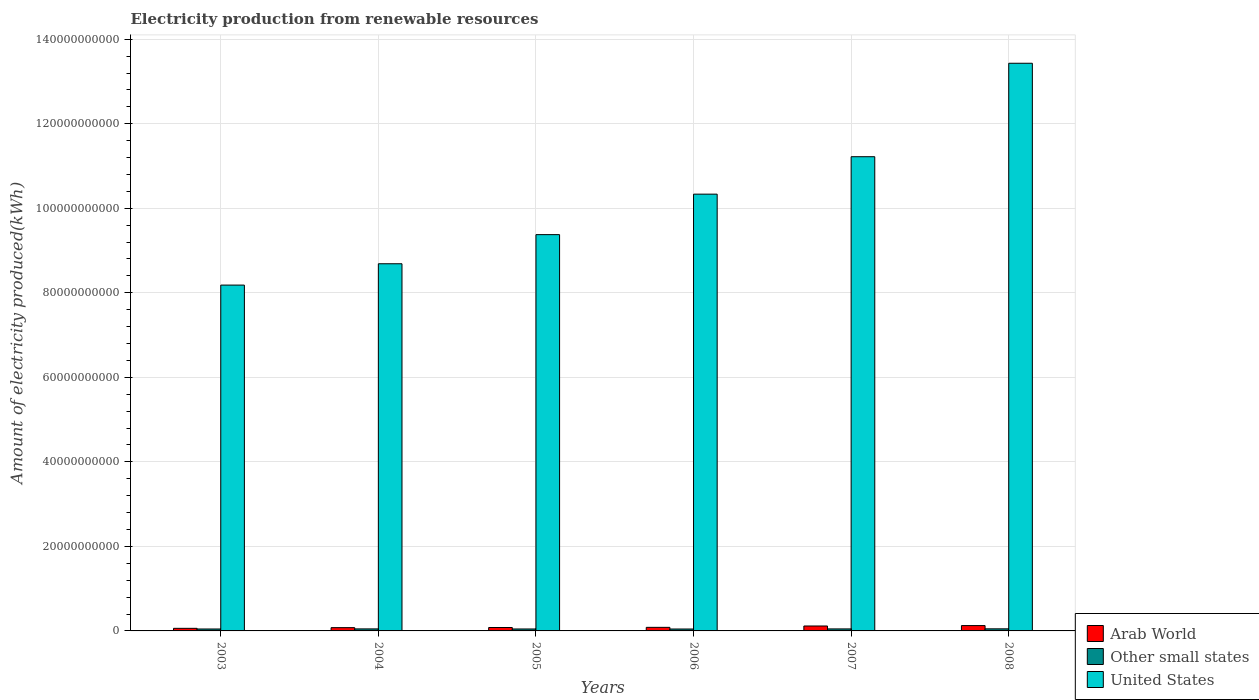How many different coloured bars are there?
Make the answer very short. 3. How many groups of bars are there?
Offer a very short reply. 6. Are the number of bars on each tick of the X-axis equal?
Give a very brief answer. Yes. In how many cases, is the number of bars for a given year not equal to the number of legend labels?
Keep it short and to the point. 0. What is the amount of electricity produced in Other small states in 2007?
Ensure brevity in your answer.  4.76e+08. Across all years, what is the maximum amount of electricity produced in Other small states?
Keep it short and to the point. 4.94e+08. Across all years, what is the minimum amount of electricity produced in Arab World?
Your response must be concise. 6.13e+08. What is the total amount of electricity produced in Arab World in the graph?
Give a very brief answer. 5.47e+09. What is the difference between the amount of electricity produced in United States in 2003 and that in 2008?
Offer a very short reply. -5.25e+1. What is the difference between the amount of electricity produced in Other small states in 2008 and the amount of electricity produced in United States in 2007?
Provide a short and direct response. -1.12e+11. What is the average amount of electricity produced in Other small states per year?
Your answer should be compact. 4.70e+08. In the year 2005, what is the difference between the amount of electricity produced in United States and amount of electricity produced in Arab World?
Give a very brief answer. 9.30e+1. What is the ratio of the amount of electricity produced in Arab World in 2006 to that in 2007?
Offer a very short reply. 0.73. Is the amount of electricity produced in Arab World in 2004 less than that in 2008?
Ensure brevity in your answer.  Yes. What is the difference between the highest and the second highest amount of electricity produced in Arab World?
Ensure brevity in your answer.  9.60e+07. What is the difference between the highest and the lowest amount of electricity produced in Other small states?
Provide a short and direct response. 4.00e+07. Is the sum of the amount of electricity produced in United States in 2004 and 2005 greater than the maximum amount of electricity produced in Other small states across all years?
Your response must be concise. Yes. What does the 2nd bar from the left in 2008 represents?
Give a very brief answer. Other small states. What does the 3rd bar from the right in 2005 represents?
Your answer should be compact. Arab World. Is it the case that in every year, the sum of the amount of electricity produced in Other small states and amount of electricity produced in United States is greater than the amount of electricity produced in Arab World?
Your response must be concise. Yes. How many bars are there?
Offer a very short reply. 18. Are all the bars in the graph horizontal?
Make the answer very short. No. How many years are there in the graph?
Your response must be concise. 6. What is the difference between two consecutive major ticks on the Y-axis?
Your response must be concise. 2.00e+1. Are the values on the major ticks of Y-axis written in scientific E-notation?
Your answer should be very brief. No. Does the graph contain any zero values?
Provide a succinct answer. No. Does the graph contain grids?
Ensure brevity in your answer.  Yes. Where does the legend appear in the graph?
Your answer should be compact. Bottom right. What is the title of the graph?
Keep it short and to the point. Electricity production from renewable resources. Does "Greece" appear as one of the legend labels in the graph?
Offer a very short reply. No. What is the label or title of the Y-axis?
Your answer should be very brief. Amount of electricity produced(kWh). What is the Amount of electricity produced(kWh) of Arab World in 2003?
Make the answer very short. 6.13e+08. What is the Amount of electricity produced(kWh) in Other small states in 2003?
Keep it short and to the point. 4.57e+08. What is the Amount of electricity produced(kWh) of United States in 2003?
Provide a succinct answer. 8.18e+1. What is the Amount of electricity produced(kWh) in Arab World in 2004?
Keep it short and to the point. 7.75e+08. What is the Amount of electricity produced(kWh) of Other small states in 2004?
Keep it short and to the point. 4.78e+08. What is the Amount of electricity produced(kWh) in United States in 2004?
Keep it short and to the point. 8.69e+1. What is the Amount of electricity produced(kWh) of Arab World in 2005?
Ensure brevity in your answer.  8.08e+08. What is the Amount of electricity produced(kWh) in Other small states in 2005?
Offer a very short reply. 4.61e+08. What is the Amount of electricity produced(kWh) in United States in 2005?
Keep it short and to the point. 9.38e+1. What is the Amount of electricity produced(kWh) in Arab World in 2006?
Give a very brief answer. 8.46e+08. What is the Amount of electricity produced(kWh) in Other small states in 2006?
Offer a very short reply. 4.54e+08. What is the Amount of electricity produced(kWh) of United States in 2006?
Keep it short and to the point. 1.03e+11. What is the Amount of electricity produced(kWh) of Arab World in 2007?
Your response must be concise. 1.17e+09. What is the Amount of electricity produced(kWh) in Other small states in 2007?
Provide a short and direct response. 4.76e+08. What is the Amount of electricity produced(kWh) in United States in 2007?
Provide a short and direct response. 1.12e+11. What is the Amount of electricity produced(kWh) of Arab World in 2008?
Provide a succinct answer. 1.26e+09. What is the Amount of electricity produced(kWh) in Other small states in 2008?
Your answer should be compact. 4.94e+08. What is the Amount of electricity produced(kWh) in United States in 2008?
Your response must be concise. 1.34e+11. Across all years, what is the maximum Amount of electricity produced(kWh) of Arab World?
Make the answer very short. 1.26e+09. Across all years, what is the maximum Amount of electricity produced(kWh) in Other small states?
Provide a succinct answer. 4.94e+08. Across all years, what is the maximum Amount of electricity produced(kWh) in United States?
Make the answer very short. 1.34e+11. Across all years, what is the minimum Amount of electricity produced(kWh) of Arab World?
Ensure brevity in your answer.  6.13e+08. Across all years, what is the minimum Amount of electricity produced(kWh) of Other small states?
Keep it short and to the point. 4.54e+08. Across all years, what is the minimum Amount of electricity produced(kWh) in United States?
Your answer should be compact. 8.18e+1. What is the total Amount of electricity produced(kWh) in Arab World in the graph?
Keep it short and to the point. 5.47e+09. What is the total Amount of electricity produced(kWh) in Other small states in the graph?
Offer a very short reply. 2.82e+09. What is the total Amount of electricity produced(kWh) of United States in the graph?
Keep it short and to the point. 6.12e+11. What is the difference between the Amount of electricity produced(kWh) in Arab World in 2003 and that in 2004?
Ensure brevity in your answer.  -1.62e+08. What is the difference between the Amount of electricity produced(kWh) in Other small states in 2003 and that in 2004?
Keep it short and to the point. -2.10e+07. What is the difference between the Amount of electricity produced(kWh) in United States in 2003 and that in 2004?
Make the answer very short. -5.04e+09. What is the difference between the Amount of electricity produced(kWh) of Arab World in 2003 and that in 2005?
Offer a very short reply. -1.95e+08. What is the difference between the Amount of electricity produced(kWh) of Other small states in 2003 and that in 2005?
Provide a succinct answer. -4.00e+06. What is the difference between the Amount of electricity produced(kWh) of United States in 2003 and that in 2005?
Provide a short and direct response. -1.19e+1. What is the difference between the Amount of electricity produced(kWh) in Arab World in 2003 and that in 2006?
Provide a short and direct response. -2.33e+08. What is the difference between the Amount of electricity produced(kWh) in United States in 2003 and that in 2006?
Ensure brevity in your answer.  -2.15e+1. What is the difference between the Amount of electricity produced(kWh) of Arab World in 2003 and that in 2007?
Keep it short and to the point. -5.53e+08. What is the difference between the Amount of electricity produced(kWh) of Other small states in 2003 and that in 2007?
Make the answer very short. -1.90e+07. What is the difference between the Amount of electricity produced(kWh) in United States in 2003 and that in 2007?
Offer a very short reply. -3.04e+1. What is the difference between the Amount of electricity produced(kWh) of Arab World in 2003 and that in 2008?
Your response must be concise. -6.49e+08. What is the difference between the Amount of electricity produced(kWh) in Other small states in 2003 and that in 2008?
Offer a terse response. -3.70e+07. What is the difference between the Amount of electricity produced(kWh) of United States in 2003 and that in 2008?
Keep it short and to the point. -5.25e+1. What is the difference between the Amount of electricity produced(kWh) of Arab World in 2004 and that in 2005?
Give a very brief answer. -3.30e+07. What is the difference between the Amount of electricity produced(kWh) of Other small states in 2004 and that in 2005?
Provide a short and direct response. 1.70e+07. What is the difference between the Amount of electricity produced(kWh) in United States in 2004 and that in 2005?
Give a very brief answer. -6.89e+09. What is the difference between the Amount of electricity produced(kWh) of Arab World in 2004 and that in 2006?
Offer a terse response. -7.10e+07. What is the difference between the Amount of electricity produced(kWh) of Other small states in 2004 and that in 2006?
Keep it short and to the point. 2.40e+07. What is the difference between the Amount of electricity produced(kWh) of United States in 2004 and that in 2006?
Ensure brevity in your answer.  -1.65e+1. What is the difference between the Amount of electricity produced(kWh) in Arab World in 2004 and that in 2007?
Offer a very short reply. -3.91e+08. What is the difference between the Amount of electricity produced(kWh) in United States in 2004 and that in 2007?
Give a very brief answer. -2.53e+1. What is the difference between the Amount of electricity produced(kWh) in Arab World in 2004 and that in 2008?
Keep it short and to the point. -4.87e+08. What is the difference between the Amount of electricity produced(kWh) in Other small states in 2004 and that in 2008?
Give a very brief answer. -1.60e+07. What is the difference between the Amount of electricity produced(kWh) of United States in 2004 and that in 2008?
Provide a succinct answer. -4.74e+1. What is the difference between the Amount of electricity produced(kWh) of Arab World in 2005 and that in 2006?
Provide a short and direct response. -3.80e+07. What is the difference between the Amount of electricity produced(kWh) of Other small states in 2005 and that in 2006?
Offer a terse response. 7.00e+06. What is the difference between the Amount of electricity produced(kWh) of United States in 2005 and that in 2006?
Your answer should be compact. -9.58e+09. What is the difference between the Amount of electricity produced(kWh) of Arab World in 2005 and that in 2007?
Your response must be concise. -3.58e+08. What is the difference between the Amount of electricity produced(kWh) of Other small states in 2005 and that in 2007?
Give a very brief answer. -1.50e+07. What is the difference between the Amount of electricity produced(kWh) in United States in 2005 and that in 2007?
Provide a succinct answer. -1.84e+1. What is the difference between the Amount of electricity produced(kWh) in Arab World in 2005 and that in 2008?
Ensure brevity in your answer.  -4.54e+08. What is the difference between the Amount of electricity produced(kWh) of Other small states in 2005 and that in 2008?
Make the answer very short. -3.30e+07. What is the difference between the Amount of electricity produced(kWh) in United States in 2005 and that in 2008?
Keep it short and to the point. -4.05e+1. What is the difference between the Amount of electricity produced(kWh) of Arab World in 2006 and that in 2007?
Offer a terse response. -3.20e+08. What is the difference between the Amount of electricity produced(kWh) of Other small states in 2006 and that in 2007?
Give a very brief answer. -2.20e+07. What is the difference between the Amount of electricity produced(kWh) of United States in 2006 and that in 2007?
Make the answer very short. -8.86e+09. What is the difference between the Amount of electricity produced(kWh) in Arab World in 2006 and that in 2008?
Give a very brief answer. -4.16e+08. What is the difference between the Amount of electricity produced(kWh) of Other small states in 2006 and that in 2008?
Provide a short and direct response. -4.00e+07. What is the difference between the Amount of electricity produced(kWh) in United States in 2006 and that in 2008?
Provide a succinct answer. -3.10e+1. What is the difference between the Amount of electricity produced(kWh) of Arab World in 2007 and that in 2008?
Your response must be concise. -9.60e+07. What is the difference between the Amount of electricity produced(kWh) in Other small states in 2007 and that in 2008?
Make the answer very short. -1.80e+07. What is the difference between the Amount of electricity produced(kWh) of United States in 2007 and that in 2008?
Provide a succinct answer. -2.21e+1. What is the difference between the Amount of electricity produced(kWh) in Arab World in 2003 and the Amount of electricity produced(kWh) in Other small states in 2004?
Make the answer very short. 1.35e+08. What is the difference between the Amount of electricity produced(kWh) of Arab World in 2003 and the Amount of electricity produced(kWh) of United States in 2004?
Provide a succinct answer. -8.63e+1. What is the difference between the Amount of electricity produced(kWh) in Other small states in 2003 and the Amount of electricity produced(kWh) in United States in 2004?
Ensure brevity in your answer.  -8.64e+1. What is the difference between the Amount of electricity produced(kWh) in Arab World in 2003 and the Amount of electricity produced(kWh) in Other small states in 2005?
Provide a short and direct response. 1.52e+08. What is the difference between the Amount of electricity produced(kWh) in Arab World in 2003 and the Amount of electricity produced(kWh) in United States in 2005?
Provide a succinct answer. -9.31e+1. What is the difference between the Amount of electricity produced(kWh) in Other small states in 2003 and the Amount of electricity produced(kWh) in United States in 2005?
Your answer should be very brief. -9.33e+1. What is the difference between the Amount of electricity produced(kWh) in Arab World in 2003 and the Amount of electricity produced(kWh) in Other small states in 2006?
Make the answer very short. 1.59e+08. What is the difference between the Amount of electricity produced(kWh) of Arab World in 2003 and the Amount of electricity produced(kWh) of United States in 2006?
Your response must be concise. -1.03e+11. What is the difference between the Amount of electricity produced(kWh) of Other small states in 2003 and the Amount of electricity produced(kWh) of United States in 2006?
Offer a terse response. -1.03e+11. What is the difference between the Amount of electricity produced(kWh) of Arab World in 2003 and the Amount of electricity produced(kWh) of Other small states in 2007?
Make the answer very short. 1.37e+08. What is the difference between the Amount of electricity produced(kWh) of Arab World in 2003 and the Amount of electricity produced(kWh) of United States in 2007?
Offer a terse response. -1.12e+11. What is the difference between the Amount of electricity produced(kWh) of Other small states in 2003 and the Amount of electricity produced(kWh) of United States in 2007?
Offer a terse response. -1.12e+11. What is the difference between the Amount of electricity produced(kWh) of Arab World in 2003 and the Amount of electricity produced(kWh) of Other small states in 2008?
Offer a terse response. 1.19e+08. What is the difference between the Amount of electricity produced(kWh) of Arab World in 2003 and the Amount of electricity produced(kWh) of United States in 2008?
Your answer should be compact. -1.34e+11. What is the difference between the Amount of electricity produced(kWh) in Other small states in 2003 and the Amount of electricity produced(kWh) in United States in 2008?
Your answer should be compact. -1.34e+11. What is the difference between the Amount of electricity produced(kWh) in Arab World in 2004 and the Amount of electricity produced(kWh) in Other small states in 2005?
Offer a terse response. 3.14e+08. What is the difference between the Amount of electricity produced(kWh) of Arab World in 2004 and the Amount of electricity produced(kWh) of United States in 2005?
Provide a short and direct response. -9.30e+1. What is the difference between the Amount of electricity produced(kWh) in Other small states in 2004 and the Amount of electricity produced(kWh) in United States in 2005?
Ensure brevity in your answer.  -9.33e+1. What is the difference between the Amount of electricity produced(kWh) of Arab World in 2004 and the Amount of electricity produced(kWh) of Other small states in 2006?
Provide a short and direct response. 3.21e+08. What is the difference between the Amount of electricity produced(kWh) of Arab World in 2004 and the Amount of electricity produced(kWh) of United States in 2006?
Offer a terse response. -1.03e+11. What is the difference between the Amount of electricity produced(kWh) of Other small states in 2004 and the Amount of electricity produced(kWh) of United States in 2006?
Your response must be concise. -1.03e+11. What is the difference between the Amount of electricity produced(kWh) of Arab World in 2004 and the Amount of electricity produced(kWh) of Other small states in 2007?
Make the answer very short. 2.99e+08. What is the difference between the Amount of electricity produced(kWh) in Arab World in 2004 and the Amount of electricity produced(kWh) in United States in 2007?
Provide a succinct answer. -1.11e+11. What is the difference between the Amount of electricity produced(kWh) in Other small states in 2004 and the Amount of electricity produced(kWh) in United States in 2007?
Provide a succinct answer. -1.12e+11. What is the difference between the Amount of electricity produced(kWh) of Arab World in 2004 and the Amount of electricity produced(kWh) of Other small states in 2008?
Your answer should be compact. 2.81e+08. What is the difference between the Amount of electricity produced(kWh) in Arab World in 2004 and the Amount of electricity produced(kWh) in United States in 2008?
Your answer should be very brief. -1.34e+11. What is the difference between the Amount of electricity produced(kWh) in Other small states in 2004 and the Amount of electricity produced(kWh) in United States in 2008?
Offer a very short reply. -1.34e+11. What is the difference between the Amount of electricity produced(kWh) in Arab World in 2005 and the Amount of electricity produced(kWh) in Other small states in 2006?
Provide a short and direct response. 3.54e+08. What is the difference between the Amount of electricity produced(kWh) in Arab World in 2005 and the Amount of electricity produced(kWh) in United States in 2006?
Ensure brevity in your answer.  -1.03e+11. What is the difference between the Amount of electricity produced(kWh) in Other small states in 2005 and the Amount of electricity produced(kWh) in United States in 2006?
Keep it short and to the point. -1.03e+11. What is the difference between the Amount of electricity produced(kWh) in Arab World in 2005 and the Amount of electricity produced(kWh) in Other small states in 2007?
Ensure brevity in your answer.  3.32e+08. What is the difference between the Amount of electricity produced(kWh) of Arab World in 2005 and the Amount of electricity produced(kWh) of United States in 2007?
Offer a terse response. -1.11e+11. What is the difference between the Amount of electricity produced(kWh) of Other small states in 2005 and the Amount of electricity produced(kWh) of United States in 2007?
Provide a succinct answer. -1.12e+11. What is the difference between the Amount of electricity produced(kWh) of Arab World in 2005 and the Amount of electricity produced(kWh) of Other small states in 2008?
Make the answer very short. 3.14e+08. What is the difference between the Amount of electricity produced(kWh) in Arab World in 2005 and the Amount of electricity produced(kWh) in United States in 2008?
Your answer should be very brief. -1.33e+11. What is the difference between the Amount of electricity produced(kWh) of Other small states in 2005 and the Amount of electricity produced(kWh) of United States in 2008?
Keep it short and to the point. -1.34e+11. What is the difference between the Amount of electricity produced(kWh) in Arab World in 2006 and the Amount of electricity produced(kWh) in Other small states in 2007?
Provide a short and direct response. 3.70e+08. What is the difference between the Amount of electricity produced(kWh) of Arab World in 2006 and the Amount of electricity produced(kWh) of United States in 2007?
Give a very brief answer. -1.11e+11. What is the difference between the Amount of electricity produced(kWh) of Other small states in 2006 and the Amount of electricity produced(kWh) of United States in 2007?
Your answer should be very brief. -1.12e+11. What is the difference between the Amount of electricity produced(kWh) in Arab World in 2006 and the Amount of electricity produced(kWh) in Other small states in 2008?
Your response must be concise. 3.52e+08. What is the difference between the Amount of electricity produced(kWh) in Arab World in 2006 and the Amount of electricity produced(kWh) in United States in 2008?
Ensure brevity in your answer.  -1.33e+11. What is the difference between the Amount of electricity produced(kWh) in Other small states in 2006 and the Amount of electricity produced(kWh) in United States in 2008?
Your answer should be very brief. -1.34e+11. What is the difference between the Amount of electricity produced(kWh) of Arab World in 2007 and the Amount of electricity produced(kWh) of Other small states in 2008?
Make the answer very short. 6.72e+08. What is the difference between the Amount of electricity produced(kWh) in Arab World in 2007 and the Amount of electricity produced(kWh) in United States in 2008?
Keep it short and to the point. -1.33e+11. What is the difference between the Amount of electricity produced(kWh) of Other small states in 2007 and the Amount of electricity produced(kWh) of United States in 2008?
Make the answer very short. -1.34e+11. What is the average Amount of electricity produced(kWh) in Arab World per year?
Give a very brief answer. 9.12e+08. What is the average Amount of electricity produced(kWh) in Other small states per year?
Provide a short and direct response. 4.70e+08. What is the average Amount of electricity produced(kWh) in United States per year?
Offer a terse response. 1.02e+11. In the year 2003, what is the difference between the Amount of electricity produced(kWh) of Arab World and Amount of electricity produced(kWh) of Other small states?
Ensure brevity in your answer.  1.56e+08. In the year 2003, what is the difference between the Amount of electricity produced(kWh) of Arab World and Amount of electricity produced(kWh) of United States?
Keep it short and to the point. -8.12e+1. In the year 2003, what is the difference between the Amount of electricity produced(kWh) of Other small states and Amount of electricity produced(kWh) of United States?
Your response must be concise. -8.14e+1. In the year 2004, what is the difference between the Amount of electricity produced(kWh) in Arab World and Amount of electricity produced(kWh) in Other small states?
Make the answer very short. 2.97e+08. In the year 2004, what is the difference between the Amount of electricity produced(kWh) of Arab World and Amount of electricity produced(kWh) of United States?
Give a very brief answer. -8.61e+1. In the year 2004, what is the difference between the Amount of electricity produced(kWh) in Other small states and Amount of electricity produced(kWh) in United States?
Make the answer very short. -8.64e+1. In the year 2005, what is the difference between the Amount of electricity produced(kWh) in Arab World and Amount of electricity produced(kWh) in Other small states?
Make the answer very short. 3.47e+08. In the year 2005, what is the difference between the Amount of electricity produced(kWh) in Arab World and Amount of electricity produced(kWh) in United States?
Your answer should be compact. -9.30e+1. In the year 2005, what is the difference between the Amount of electricity produced(kWh) of Other small states and Amount of electricity produced(kWh) of United States?
Make the answer very short. -9.33e+1. In the year 2006, what is the difference between the Amount of electricity produced(kWh) of Arab World and Amount of electricity produced(kWh) of Other small states?
Your answer should be compact. 3.92e+08. In the year 2006, what is the difference between the Amount of electricity produced(kWh) in Arab World and Amount of electricity produced(kWh) in United States?
Offer a terse response. -1.02e+11. In the year 2006, what is the difference between the Amount of electricity produced(kWh) in Other small states and Amount of electricity produced(kWh) in United States?
Offer a terse response. -1.03e+11. In the year 2007, what is the difference between the Amount of electricity produced(kWh) in Arab World and Amount of electricity produced(kWh) in Other small states?
Provide a short and direct response. 6.90e+08. In the year 2007, what is the difference between the Amount of electricity produced(kWh) in Arab World and Amount of electricity produced(kWh) in United States?
Give a very brief answer. -1.11e+11. In the year 2007, what is the difference between the Amount of electricity produced(kWh) of Other small states and Amount of electricity produced(kWh) of United States?
Ensure brevity in your answer.  -1.12e+11. In the year 2008, what is the difference between the Amount of electricity produced(kWh) in Arab World and Amount of electricity produced(kWh) in Other small states?
Ensure brevity in your answer.  7.68e+08. In the year 2008, what is the difference between the Amount of electricity produced(kWh) of Arab World and Amount of electricity produced(kWh) of United States?
Make the answer very short. -1.33e+11. In the year 2008, what is the difference between the Amount of electricity produced(kWh) of Other small states and Amount of electricity produced(kWh) of United States?
Provide a succinct answer. -1.34e+11. What is the ratio of the Amount of electricity produced(kWh) of Arab World in 2003 to that in 2004?
Offer a very short reply. 0.79. What is the ratio of the Amount of electricity produced(kWh) of Other small states in 2003 to that in 2004?
Keep it short and to the point. 0.96. What is the ratio of the Amount of electricity produced(kWh) in United States in 2003 to that in 2004?
Your answer should be compact. 0.94. What is the ratio of the Amount of electricity produced(kWh) of Arab World in 2003 to that in 2005?
Your response must be concise. 0.76. What is the ratio of the Amount of electricity produced(kWh) in United States in 2003 to that in 2005?
Your response must be concise. 0.87. What is the ratio of the Amount of electricity produced(kWh) in Arab World in 2003 to that in 2006?
Offer a very short reply. 0.72. What is the ratio of the Amount of electricity produced(kWh) in Other small states in 2003 to that in 2006?
Keep it short and to the point. 1.01. What is the ratio of the Amount of electricity produced(kWh) in United States in 2003 to that in 2006?
Your answer should be compact. 0.79. What is the ratio of the Amount of electricity produced(kWh) in Arab World in 2003 to that in 2007?
Your answer should be compact. 0.53. What is the ratio of the Amount of electricity produced(kWh) of Other small states in 2003 to that in 2007?
Provide a succinct answer. 0.96. What is the ratio of the Amount of electricity produced(kWh) in United States in 2003 to that in 2007?
Your answer should be compact. 0.73. What is the ratio of the Amount of electricity produced(kWh) of Arab World in 2003 to that in 2008?
Your answer should be very brief. 0.49. What is the ratio of the Amount of electricity produced(kWh) in Other small states in 2003 to that in 2008?
Your answer should be compact. 0.93. What is the ratio of the Amount of electricity produced(kWh) in United States in 2003 to that in 2008?
Make the answer very short. 0.61. What is the ratio of the Amount of electricity produced(kWh) in Arab World in 2004 to that in 2005?
Make the answer very short. 0.96. What is the ratio of the Amount of electricity produced(kWh) of Other small states in 2004 to that in 2005?
Your response must be concise. 1.04. What is the ratio of the Amount of electricity produced(kWh) in United States in 2004 to that in 2005?
Ensure brevity in your answer.  0.93. What is the ratio of the Amount of electricity produced(kWh) in Arab World in 2004 to that in 2006?
Your answer should be compact. 0.92. What is the ratio of the Amount of electricity produced(kWh) of Other small states in 2004 to that in 2006?
Keep it short and to the point. 1.05. What is the ratio of the Amount of electricity produced(kWh) in United States in 2004 to that in 2006?
Ensure brevity in your answer.  0.84. What is the ratio of the Amount of electricity produced(kWh) in Arab World in 2004 to that in 2007?
Your response must be concise. 0.66. What is the ratio of the Amount of electricity produced(kWh) of Other small states in 2004 to that in 2007?
Keep it short and to the point. 1. What is the ratio of the Amount of electricity produced(kWh) in United States in 2004 to that in 2007?
Your answer should be compact. 0.77. What is the ratio of the Amount of electricity produced(kWh) of Arab World in 2004 to that in 2008?
Provide a succinct answer. 0.61. What is the ratio of the Amount of electricity produced(kWh) of Other small states in 2004 to that in 2008?
Give a very brief answer. 0.97. What is the ratio of the Amount of electricity produced(kWh) in United States in 2004 to that in 2008?
Your answer should be very brief. 0.65. What is the ratio of the Amount of electricity produced(kWh) in Arab World in 2005 to that in 2006?
Give a very brief answer. 0.96. What is the ratio of the Amount of electricity produced(kWh) in Other small states in 2005 to that in 2006?
Keep it short and to the point. 1.02. What is the ratio of the Amount of electricity produced(kWh) of United States in 2005 to that in 2006?
Make the answer very short. 0.91. What is the ratio of the Amount of electricity produced(kWh) in Arab World in 2005 to that in 2007?
Provide a succinct answer. 0.69. What is the ratio of the Amount of electricity produced(kWh) in Other small states in 2005 to that in 2007?
Your response must be concise. 0.97. What is the ratio of the Amount of electricity produced(kWh) of United States in 2005 to that in 2007?
Make the answer very short. 0.84. What is the ratio of the Amount of electricity produced(kWh) of Arab World in 2005 to that in 2008?
Keep it short and to the point. 0.64. What is the ratio of the Amount of electricity produced(kWh) of Other small states in 2005 to that in 2008?
Ensure brevity in your answer.  0.93. What is the ratio of the Amount of electricity produced(kWh) of United States in 2005 to that in 2008?
Your response must be concise. 0.7. What is the ratio of the Amount of electricity produced(kWh) of Arab World in 2006 to that in 2007?
Offer a terse response. 0.73. What is the ratio of the Amount of electricity produced(kWh) of Other small states in 2006 to that in 2007?
Provide a short and direct response. 0.95. What is the ratio of the Amount of electricity produced(kWh) in United States in 2006 to that in 2007?
Offer a terse response. 0.92. What is the ratio of the Amount of electricity produced(kWh) in Arab World in 2006 to that in 2008?
Your answer should be compact. 0.67. What is the ratio of the Amount of electricity produced(kWh) in Other small states in 2006 to that in 2008?
Provide a short and direct response. 0.92. What is the ratio of the Amount of electricity produced(kWh) of United States in 2006 to that in 2008?
Provide a short and direct response. 0.77. What is the ratio of the Amount of electricity produced(kWh) in Arab World in 2007 to that in 2008?
Make the answer very short. 0.92. What is the ratio of the Amount of electricity produced(kWh) in Other small states in 2007 to that in 2008?
Provide a succinct answer. 0.96. What is the ratio of the Amount of electricity produced(kWh) of United States in 2007 to that in 2008?
Offer a very short reply. 0.84. What is the difference between the highest and the second highest Amount of electricity produced(kWh) in Arab World?
Offer a very short reply. 9.60e+07. What is the difference between the highest and the second highest Amount of electricity produced(kWh) of Other small states?
Your answer should be compact. 1.60e+07. What is the difference between the highest and the second highest Amount of electricity produced(kWh) of United States?
Offer a terse response. 2.21e+1. What is the difference between the highest and the lowest Amount of electricity produced(kWh) in Arab World?
Offer a very short reply. 6.49e+08. What is the difference between the highest and the lowest Amount of electricity produced(kWh) of Other small states?
Keep it short and to the point. 4.00e+07. What is the difference between the highest and the lowest Amount of electricity produced(kWh) in United States?
Your answer should be very brief. 5.25e+1. 